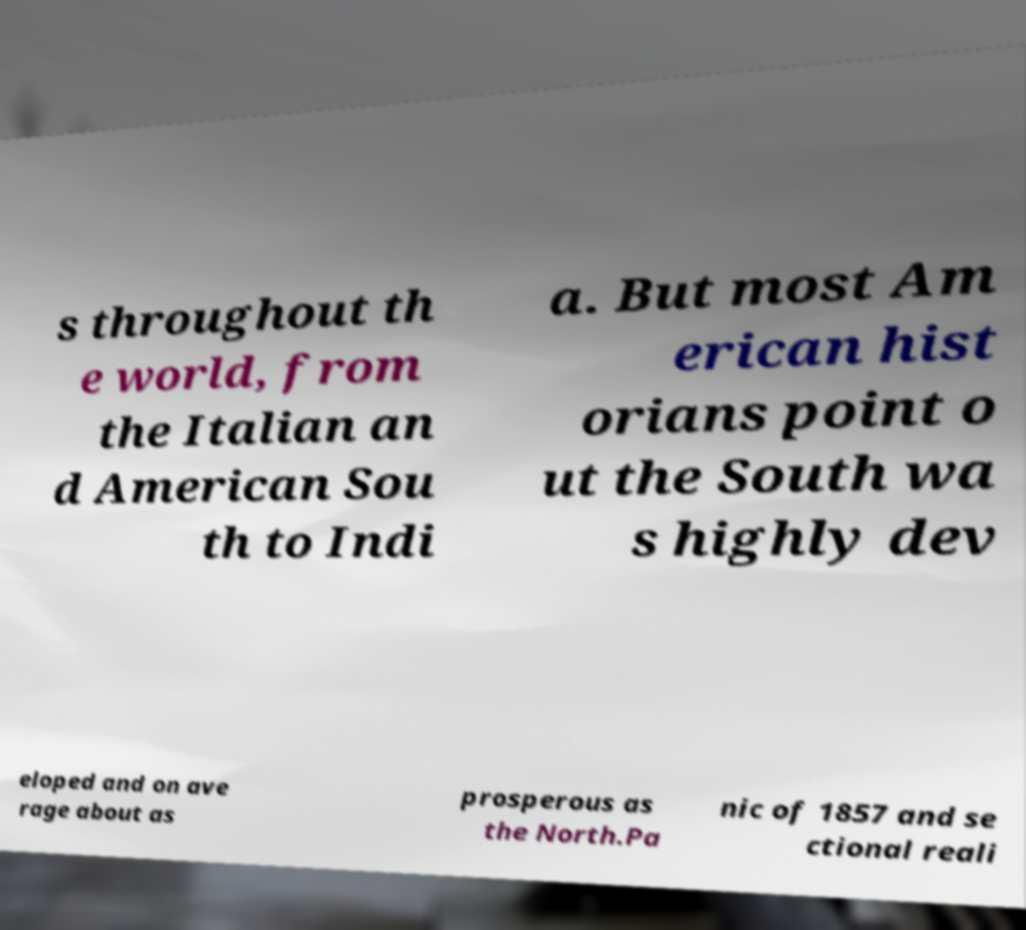Please identify and transcribe the text found in this image. s throughout th e world, from the Italian an d American Sou th to Indi a. But most Am erican hist orians point o ut the South wa s highly dev eloped and on ave rage about as prosperous as the North.Pa nic of 1857 and se ctional reali 